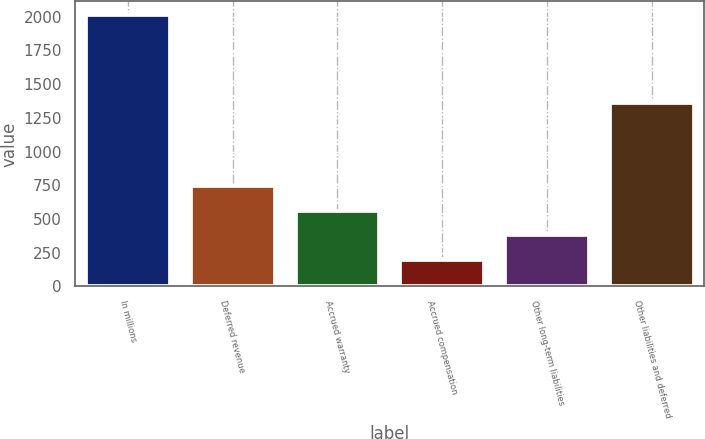<chart> <loc_0><loc_0><loc_500><loc_500><bar_chart><fcel>In millions<fcel>Deferred revenue<fcel>Accrued warranty<fcel>Accrued compensation<fcel>Other long-term liabilities<fcel>Other liabilities and deferred<nl><fcel>2015<fcel>743.8<fcel>562.2<fcel>199<fcel>380.6<fcel>1358<nl></chart> 